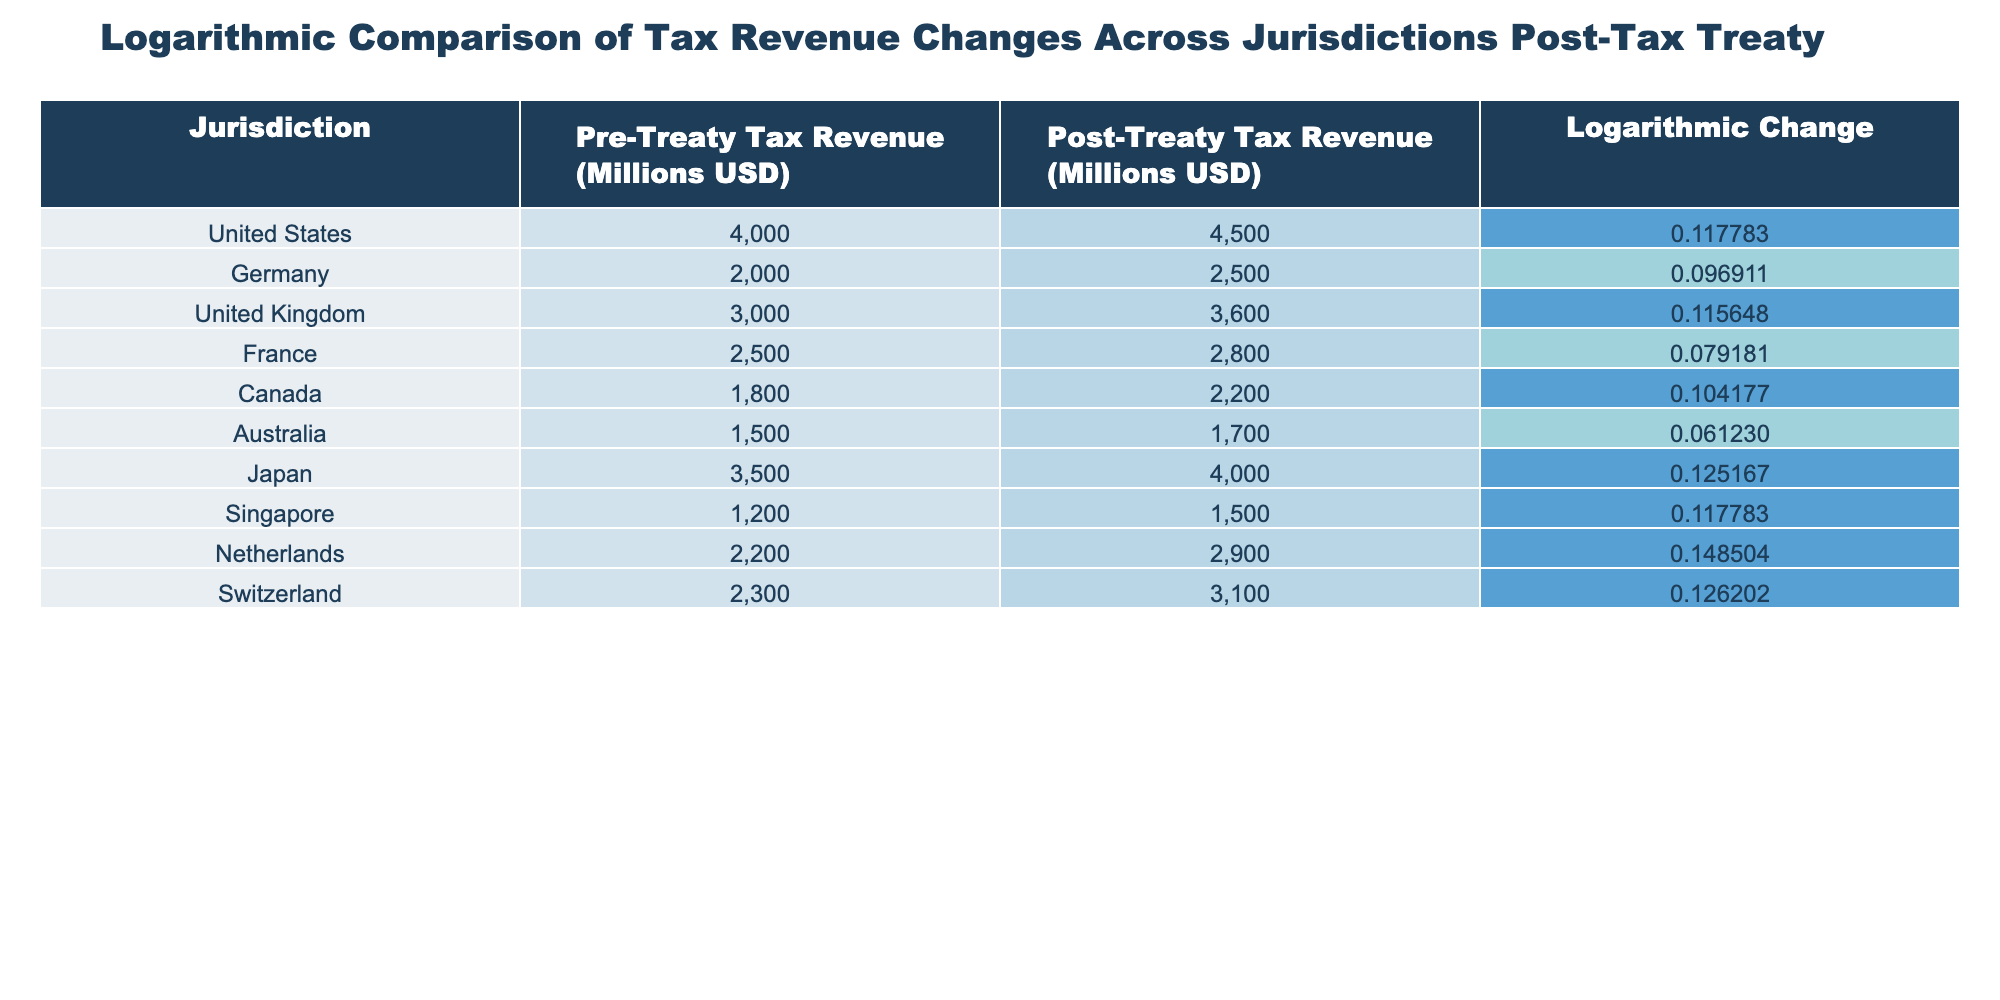What is the logarithmic change in tax revenue for the United Kingdom? The table shows that the logarithmic change for the United Kingdom is listed in the 'Logarithmic Change' column next to its name. From the table, it is 0.115648.
Answer: 0.115648 Which jurisdiction experienced the highest logarithmic change in tax revenue? By comparing the values in the 'Logarithmic Change' column, Netherlands has the highest value at 0.148504, which is greater than the rest of the jurisdictions.
Answer: Netherlands What is the pre-treaty tax revenue for Canada? The 'Pre-Treaty Tax Revenue (Millions USD)' column indicates that the pre-treaty tax revenue for Canada is 1800 million USD as shown in the table.
Answer: 1800 million USD Is the post-treaty tax revenue for Australia greater than that for France? The table lists post-treaty tax revenue for Australia at 1700 million USD and for France at 2800 million USD. Since 1700 is less than 2800, the statement is false.
Answer: No What is the average logarithmic change of tax revenue across all jurisdictions? To calculate the average, sum all logarithmic changes (0.117783 + 0.096911 + 0.115648 + 0.079181 + 0.104177 + 0.061230 + 0.125167 + 0.117783 + 0.148504 + 0.126202 = 1.026474) and then divide by the number of jurisdictions (10). The average is 1.026474 / 10 = 0.1026474.
Answer: Approximately 0.1026 What is the difference in logarithmic change between Japan and the United States? The logarithmic change for Japan is 0.125167, and for the United States, it is 0.117783. To find the difference, subtract the United States value from Japan's value (0.125167 - 0.117783 = 0.007384).
Answer: 0.007384 Which jurisdictions have a logarithmic change greater than 0.1? By inspecting the 'Logarithmic Change' column, the jurisdictions with values greater than 0.1 are the United Kingdom (0.115648), Japan (0.125167), Netherlands (0.148504), and Switzerland (0.126202). These four meet the condition.
Answer: United Kingdom, Japan, Netherlands, Switzerland Are the pre-treaty tax revenues for the United States and Germany equal? The table shows that the pre-treaty tax revenue for the United States is 4000 million USD while for Germany, it is 2000 million USD. Since 4000 does not equal 2000, the answer is false.
Answer: No What is the total post-treaty tax revenue for all jurisdictions combined? To find the total post-treaty revenue, add all post-treaty values: (4500 + 2500 + 3600 + 2800 + 2200 + 1700 + 4000 + 1500 + 2900 + 3100 = 25000). Therefore, the total post-treaty tax revenue is 25000 million USD.
Answer: 25000 million USD 